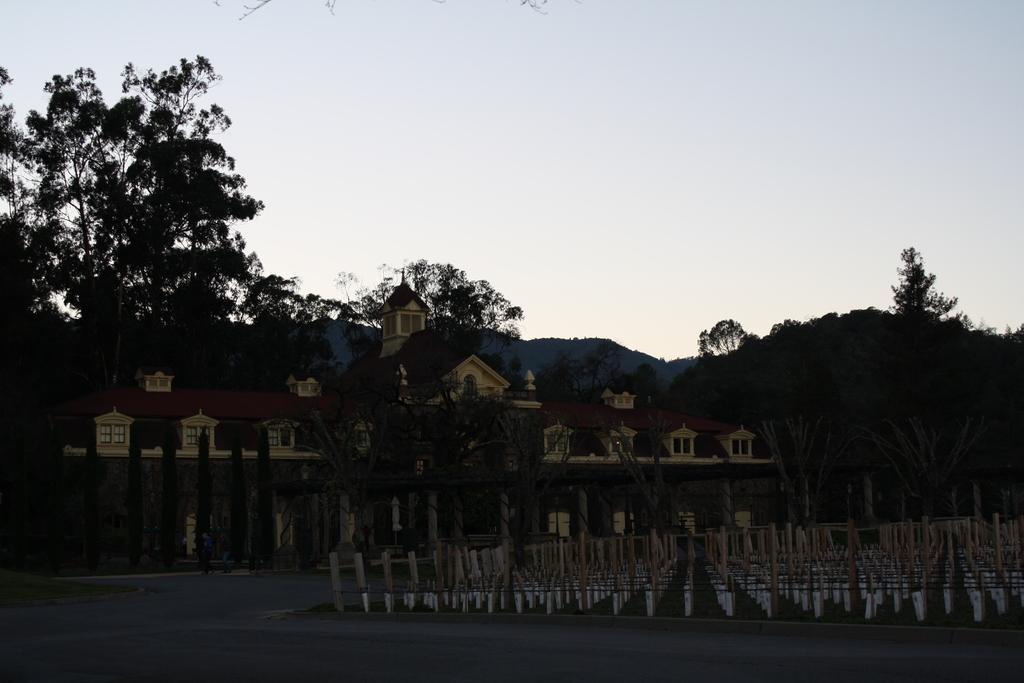Could you give a brief overview of what you see in this image? In this image we can see a road. Also there are poles. And there are trees. And there is a building. In the background there is sky. 